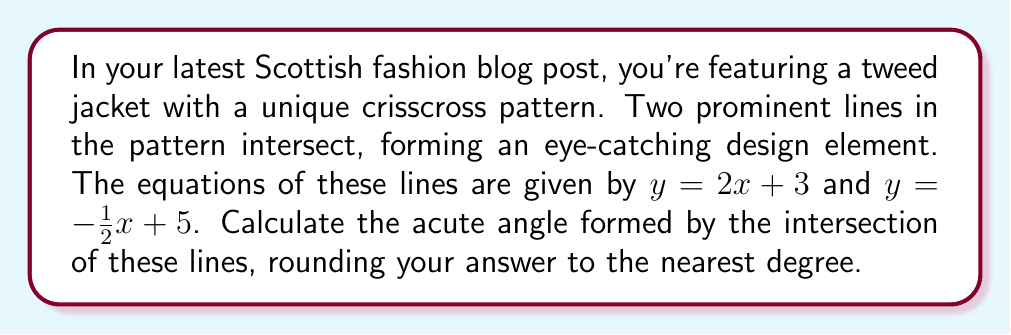Can you solve this math problem? To find the angle between two intersecting lines, we can use the following steps:

1) First, we need to find the slopes of both lines. 
   For $y = 2x + 3$, the slope $m_1 = 2$
   For $y = -\frac{1}{2}x + 5$, the slope $m_2 = -\frac{1}{2}$

2) The formula for the angle $\theta$ between two lines with slopes $m_1$ and $m_2$ is:

   $$\tan \theta = \left|\frac{m_1 - m_2}{1 + m_1m_2}\right|$$

3) Let's substitute our values:

   $$\tan \theta = \left|\frac{2 - (-\frac{1}{2})}{1 + 2(-\frac{1}{2})}\right| = \left|\frac{2 + \frac{1}{2}}{1 - 1}\right| = \left|\frac{\frac{5}{2}}{0}\right|$$

4) Simplify:
   $$\tan \theta = \frac{5}{2} = 2.5$$

5) To find $\theta$, we need to take the inverse tangent (arctan or $\tan^{-1}$):

   $$\theta = \tan^{-1}(2.5)$$

6) Using a calculator or computer, we get:

   $$\theta \approx 68.1986...°$$

7) Rounding to the nearest degree:

   $$\theta \approx 68°$$

Note: This gives us the acute angle. The obtuse angle would be $180° - 68° = 112°$.
Answer: 68° 